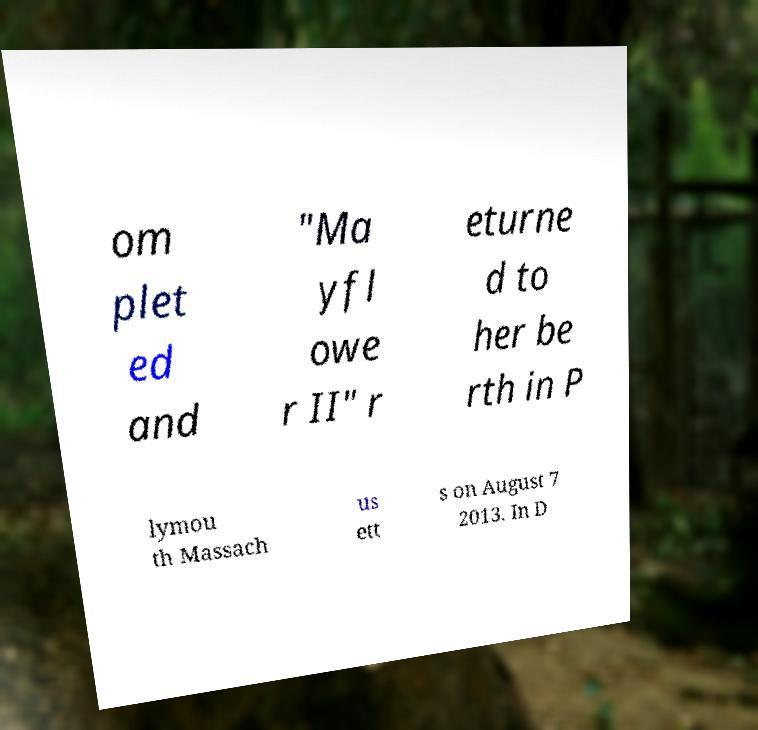What messages or text are displayed in this image? I need them in a readable, typed format. om plet ed and "Ma yfl owe r II" r eturne d to her be rth in P lymou th Massach us ett s on August 7 2013. In D 